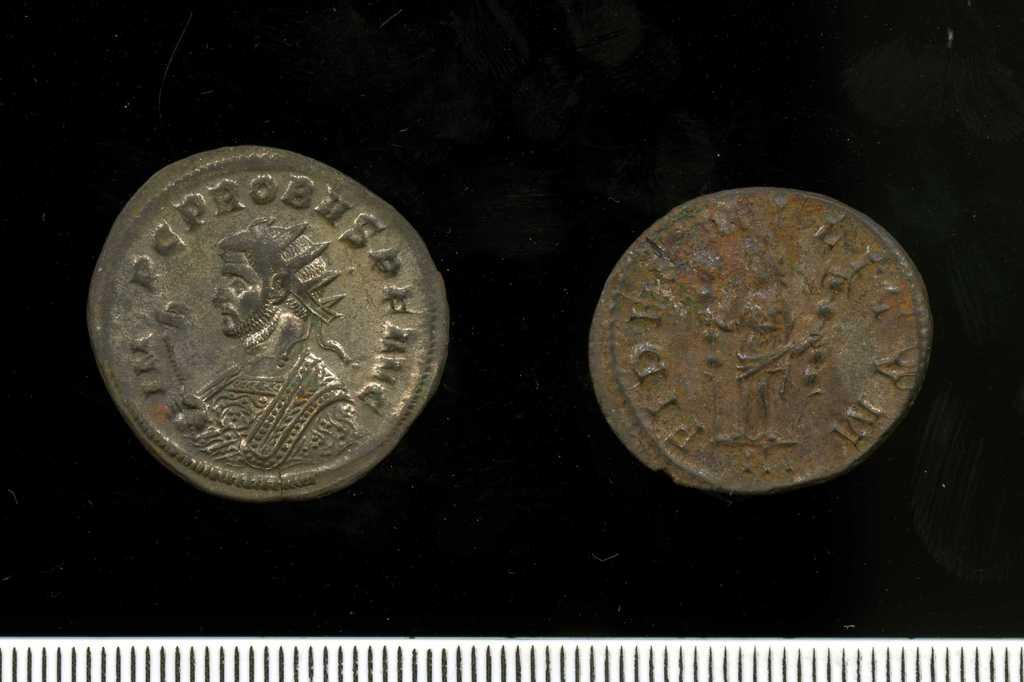How many coins are visible in the image? There are two coins in the image. What can be found on the surface of the coins? The coins have text and figures on them. What is the background of the coins in the image? The coins are placed on a black cloth. What is the color and shape of the object at the bottom of the image? There is a white object with black lines at the bottom of the image. How many lizards are sitting on the coins in the image? There are no lizards present in the image; it only features two coins on a black cloth. What type of knowledge can be gained from the text on the coins? The text on the coins may provide information about their origin, value, or historical significance, but it does not convey general knowledge. 